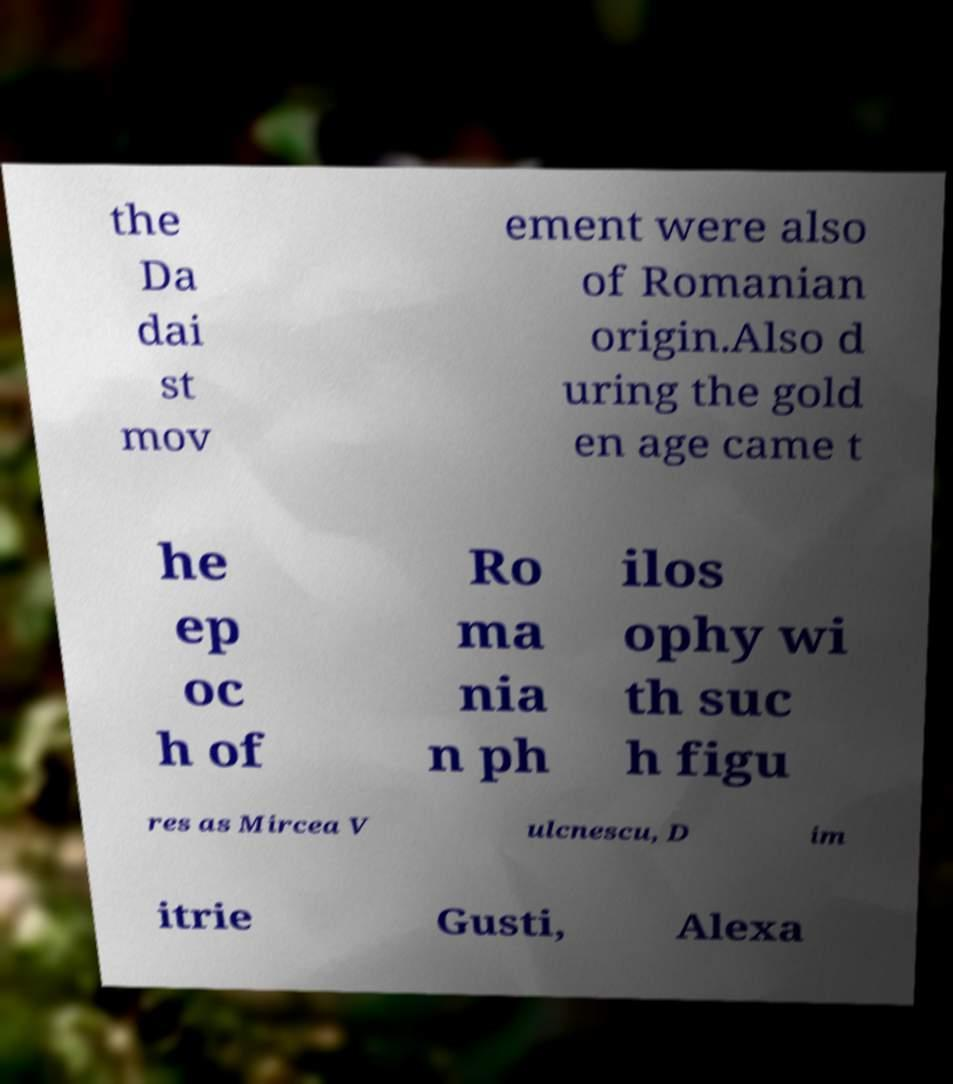Please read and relay the text visible in this image. What does it say? the Da dai st mov ement were also of Romanian origin.Also d uring the gold en age came t he ep oc h of Ro ma nia n ph ilos ophy wi th suc h figu res as Mircea V ulcnescu, D im itrie Gusti, Alexa 